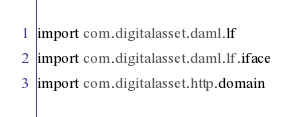<code> <loc_0><loc_0><loc_500><loc_500><_Scala_>import com.digitalasset.daml.lf
import com.digitalasset.daml.lf.iface
import com.digitalasset.http.domain</code> 